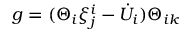Convert formula to latex. <formula><loc_0><loc_0><loc_500><loc_500>g = ( \Theta _ { i } \xi _ { j } ^ { i } - { \dot { U } } _ { i } ) \Theta _ { i k }</formula> 